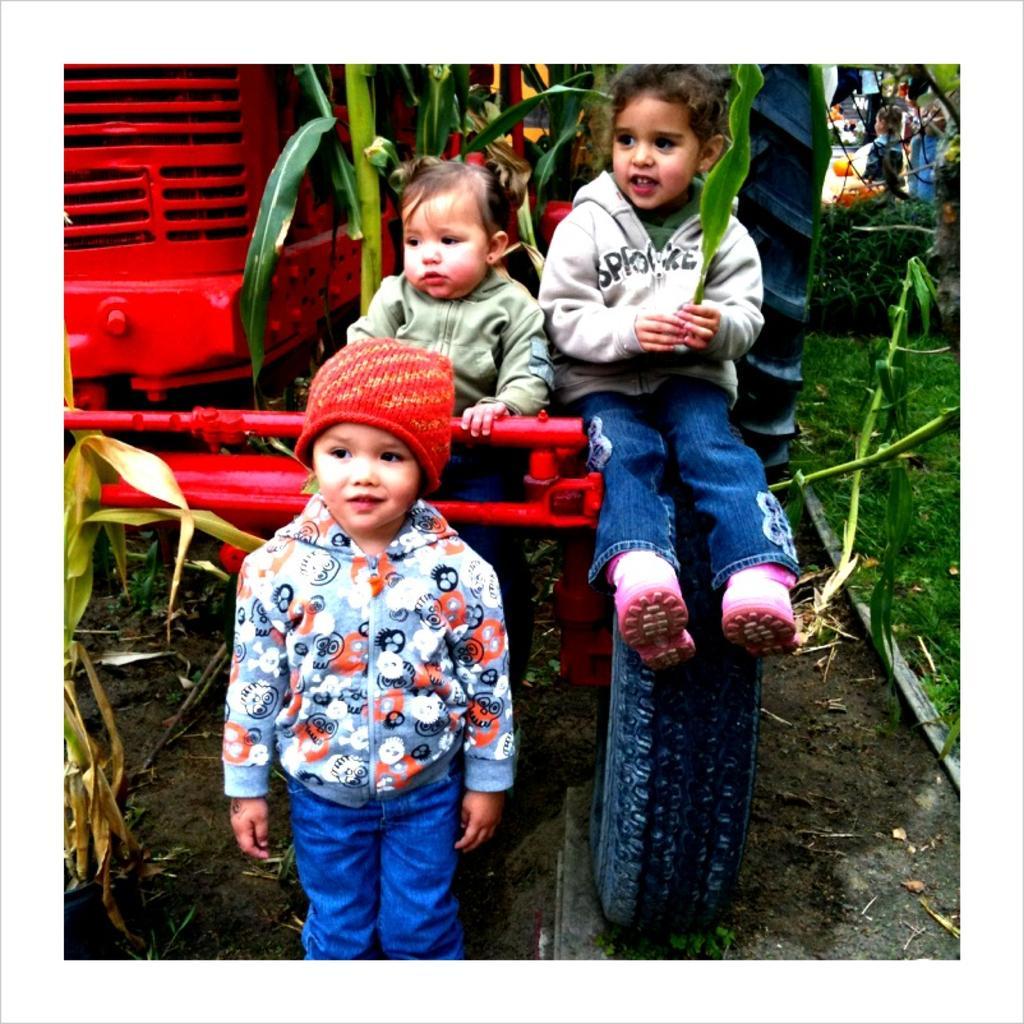Can you describe this image briefly? In this picture there three small kids, one is standing and two are sitting on the tractor wheel. Behind there is a red color tractor parked on the ground. 